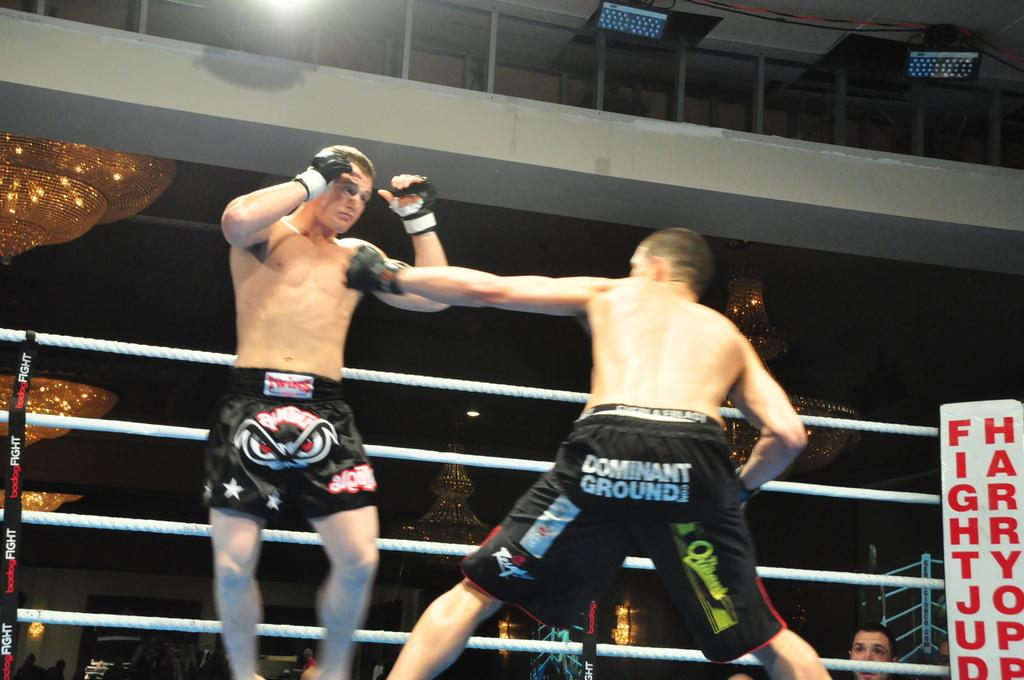<image>
Present a compact description of the photo's key features. boxers with one of them wearing shorts that say 'dominant ground' 